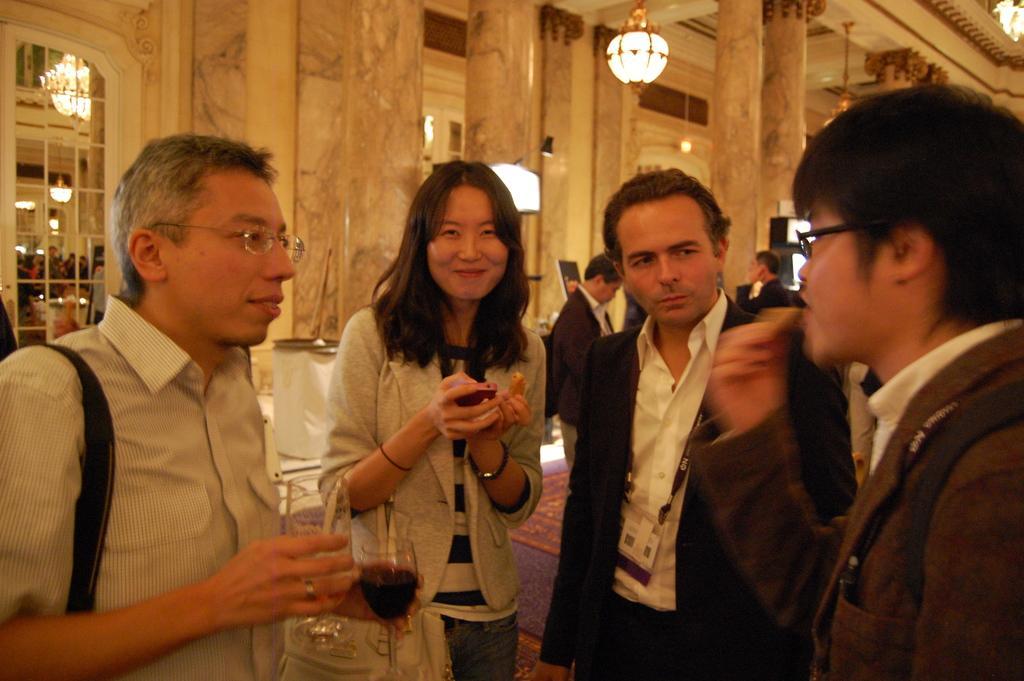Can you describe this image briefly? In the image we can see there are four people standing wearing clothes and it looks like they are talking to each other, two of them are wearing spectacles and the left side person is holding the wine glasses in hands. Here we can see chandeliers, glass door, floor, pillars and the wall. Behind them there are other people standing and wearing clothes. 